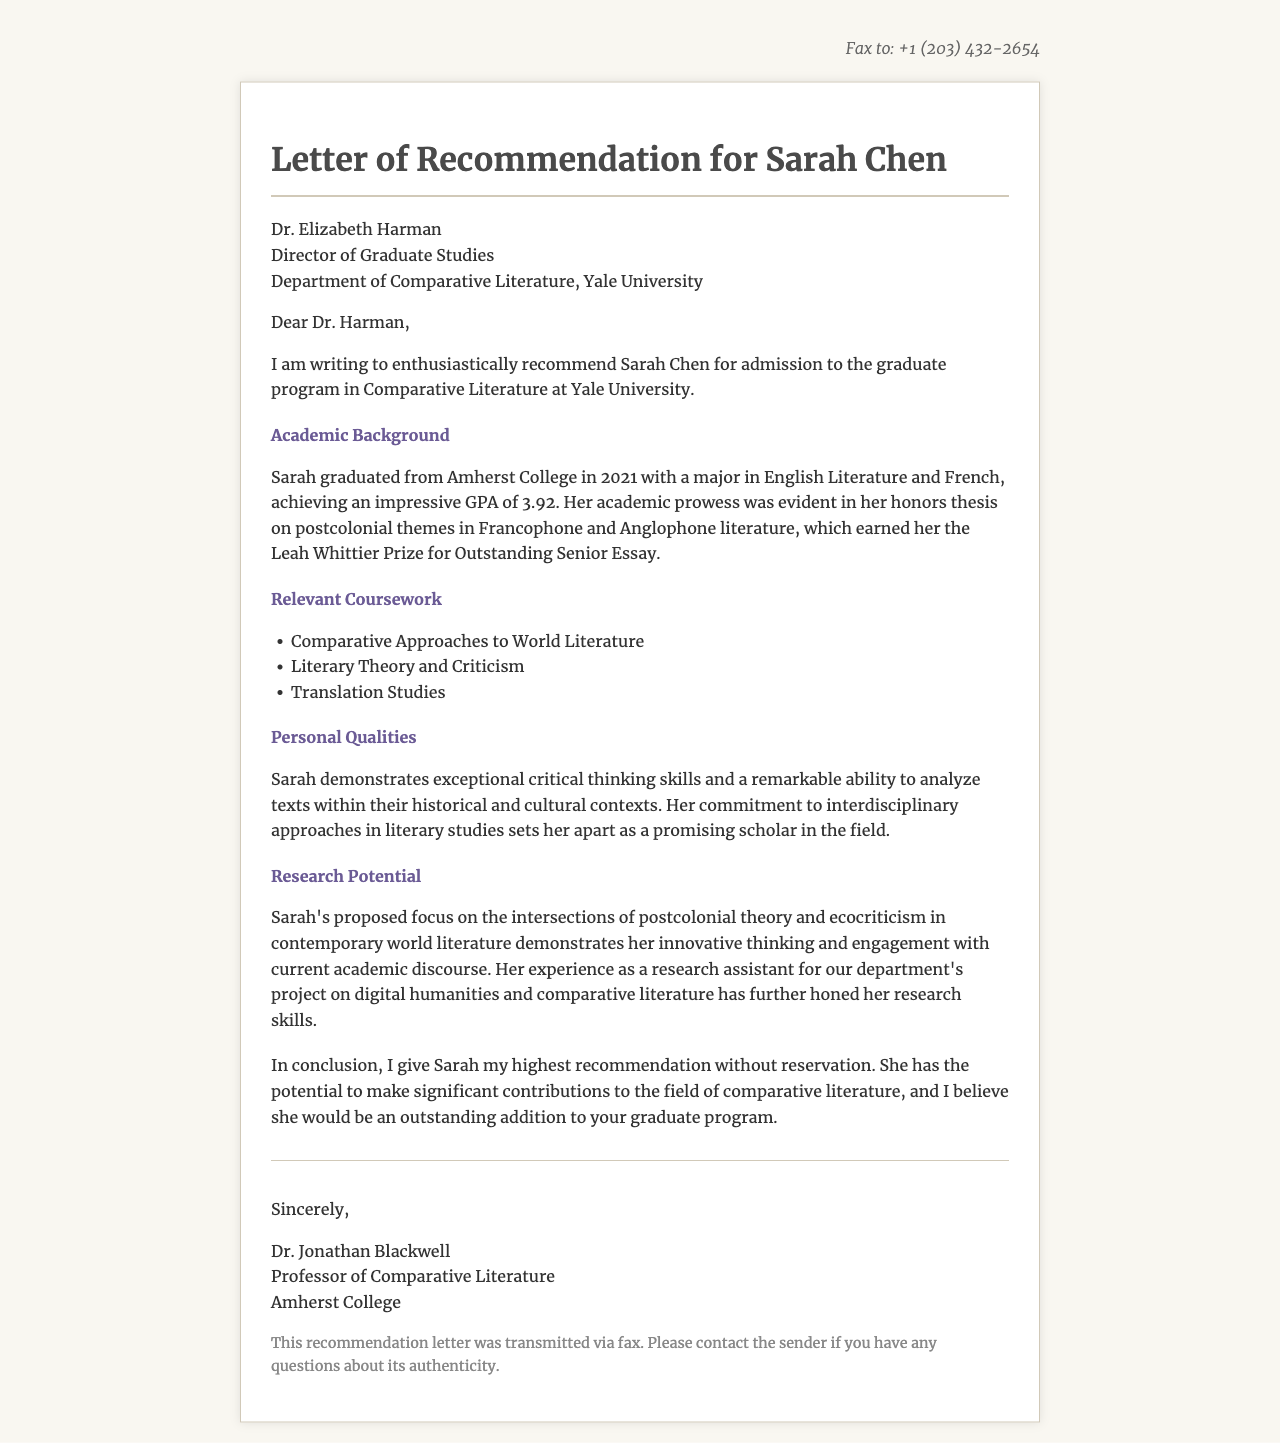What is the name of the student applying for the graduate program? The letter is a recommendation for Sarah Chen, who is applying for a graduate program in Comparative Literature.
Answer: Sarah Chen Who is the director of graduate studies at Yale University mentioned in the fax? The letter addresses Dr. Elizabeth Harman, who is the Director of Graduate Studies in the Department of Comparative Literature.
Answer: Dr. Elizabeth Harman What award did Sarah Chen receive for her honors thesis? The letter mentions that she earned the Leah Whittier Prize for Outstanding Senior Essay for her honors thesis.
Answer: Leah Whittier Prize What GPA did Sarah Chen achieve in her studies? The document states that Sarah graduated with an impressive GPA of 3.92.
Answer: 3.92 What is the proposed focus of Sarah's research? The letter describes her proposed focus on intersections of postcolonial theory and ecocriticism in contemporary world literature.
Answer: Postcolonial theory and ecocriticism How many relevant coursework items are listed in the document? The document lists three items under the relevant coursework section.
Answer: 3 Who is the sender of the letter and what is their title? The fax is signed by Dr. Jonathan Blackwell, who is a Professor of Comparative Literature at Amherst College.
Answer: Dr. Jonathan Blackwell What format was the recommendation letter transmitted in? The document notes that this recommendation letter was transmitted via fax.
Answer: fax 